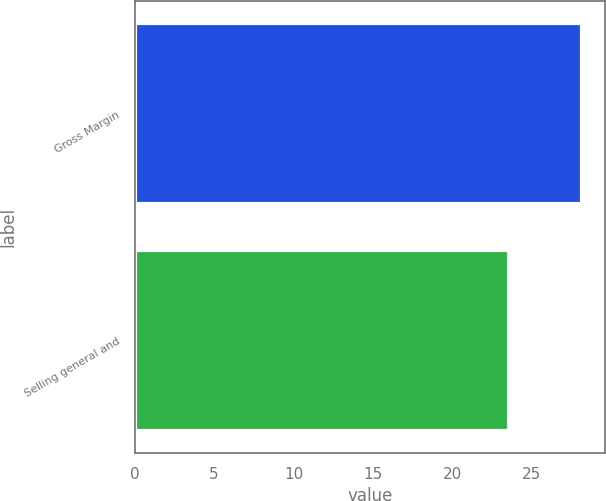<chart> <loc_0><loc_0><loc_500><loc_500><bar_chart><fcel>Gross Margin<fcel>Selling general and<nl><fcel>28.2<fcel>23.6<nl></chart> 